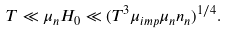Convert formula to latex. <formula><loc_0><loc_0><loc_500><loc_500>T \ll \mu _ { n } H _ { 0 } \ll ( T ^ { 3 } \mu _ { i m p } \mu _ { n } n _ { n } ) ^ { 1 / 4 } .</formula> 